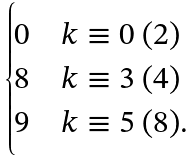Convert formula to latex. <formula><loc_0><loc_0><loc_500><loc_500>\begin{cases} 0 & k \equiv 0 \ ( 2 ) \\ 8 & k \equiv 3 \ ( 4 ) \\ 9 & k \equiv 5 \ ( 8 ) . \end{cases}</formula> 